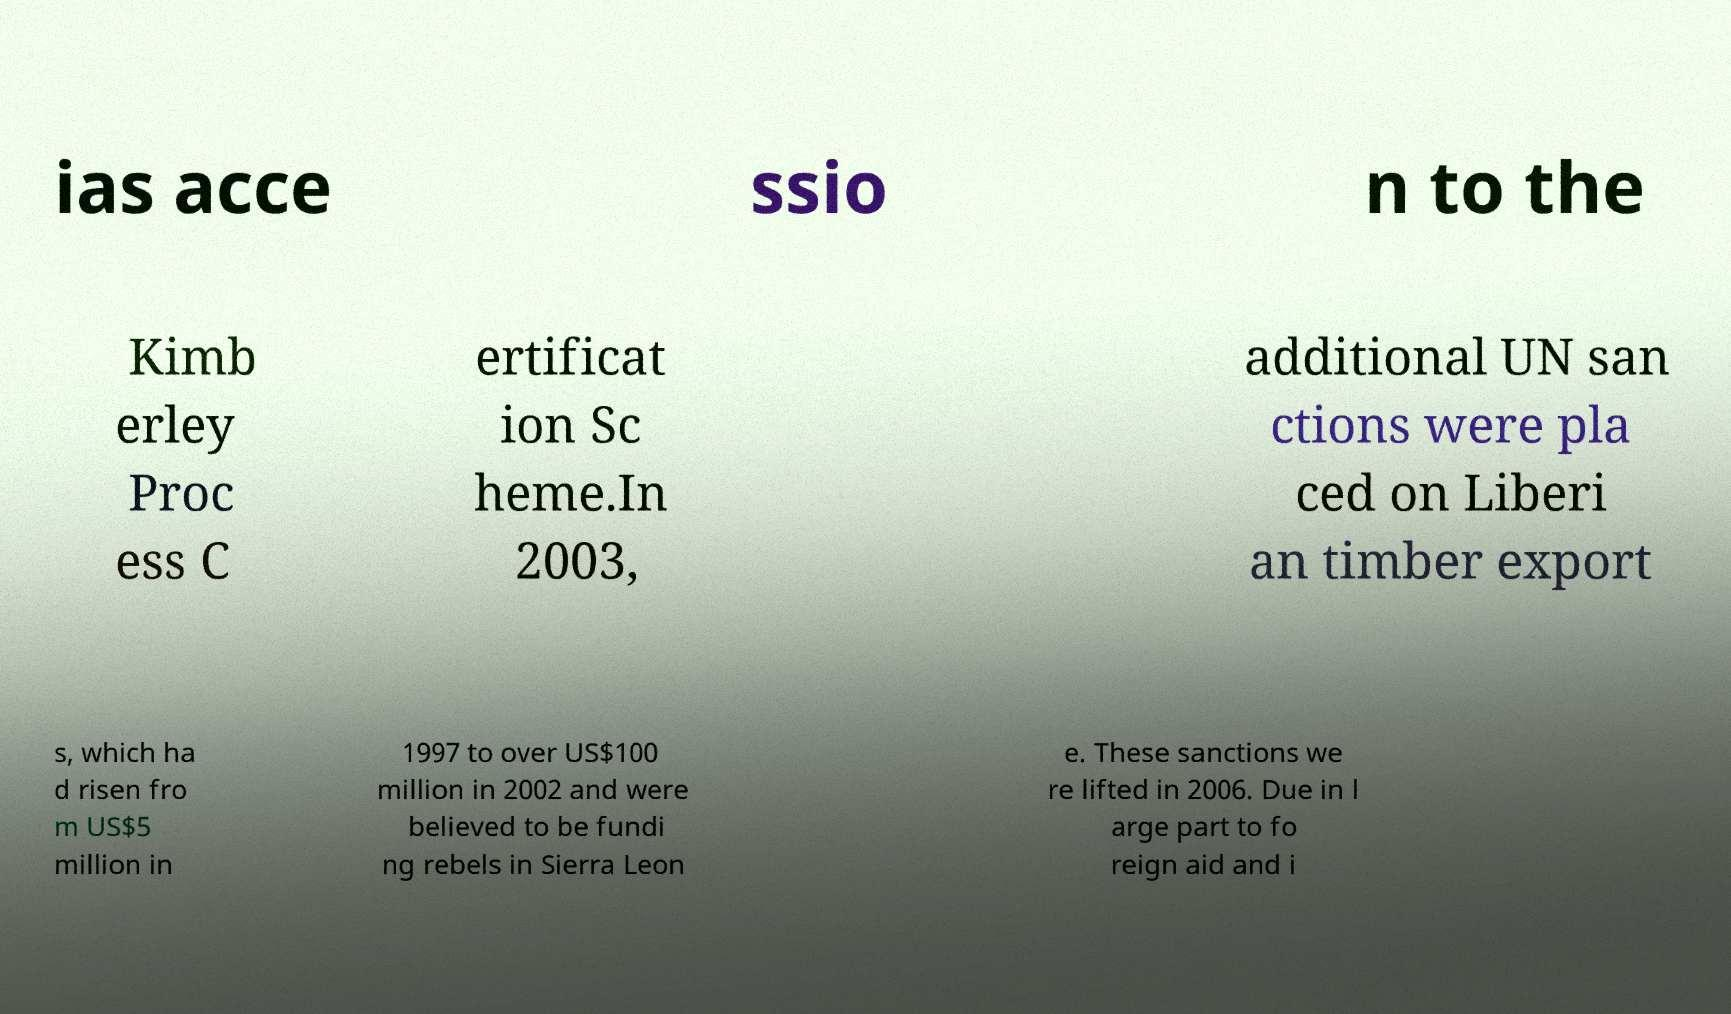What messages or text are displayed in this image? I need them in a readable, typed format. ias acce ssio n to the Kimb erley Proc ess C ertificat ion Sc heme.In 2003, additional UN san ctions were pla ced on Liberi an timber export s, which ha d risen fro m US$5 million in 1997 to over US$100 million in 2002 and were believed to be fundi ng rebels in Sierra Leon e. These sanctions we re lifted in 2006. Due in l arge part to fo reign aid and i 